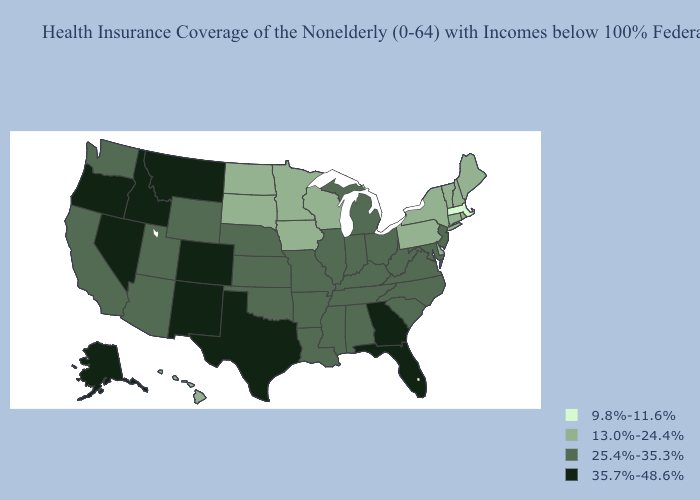Name the states that have a value in the range 35.7%-48.6%?
Be succinct. Alaska, Colorado, Florida, Georgia, Idaho, Montana, Nevada, New Mexico, Oregon, Texas. Does Connecticut have the lowest value in the Northeast?
Quick response, please. No. Does Kentucky have a lower value than Kansas?
Be succinct. No. Does Florida have a higher value than Nevada?
Give a very brief answer. No. Does Massachusetts have the lowest value in the USA?
Answer briefly. Yes. Does Utah have the same value as Alabama?
Keep it brief. Yes. What is the value of New York?
Keep it brief. 13.0%-24.4%. Name the states that have a value in the range 25.4%-35.3%?
Be succinct. Alabama, Arizona, Arkansas, California, Illinois, Indiana, Kansas, Kentucky, Louisiana, Maryland, Michigan, Mississippi, Missouri, Nebraska, New Jersey, North Carolina, Ohio, Oklahoma, South Carolina, Tennessee, Utah, Virginia, Washington, West Virginia, Wyoming. Name the states that have a value in the range 9.8%-11.6%?
Keep it brief. Massachusetts. What is the value of North Dakota?
Give a very brief answer. 13.0%-24.4%. Does Arkansas have a higher value than Virginia?
Short answer required. No. Does the map have missing data?
Keep it brief. No. What is the value of Maryland?
Short answer required. 25.4%-35.3%. Does Georgia have the same value as Tennessee?
Keep it brief. No. 